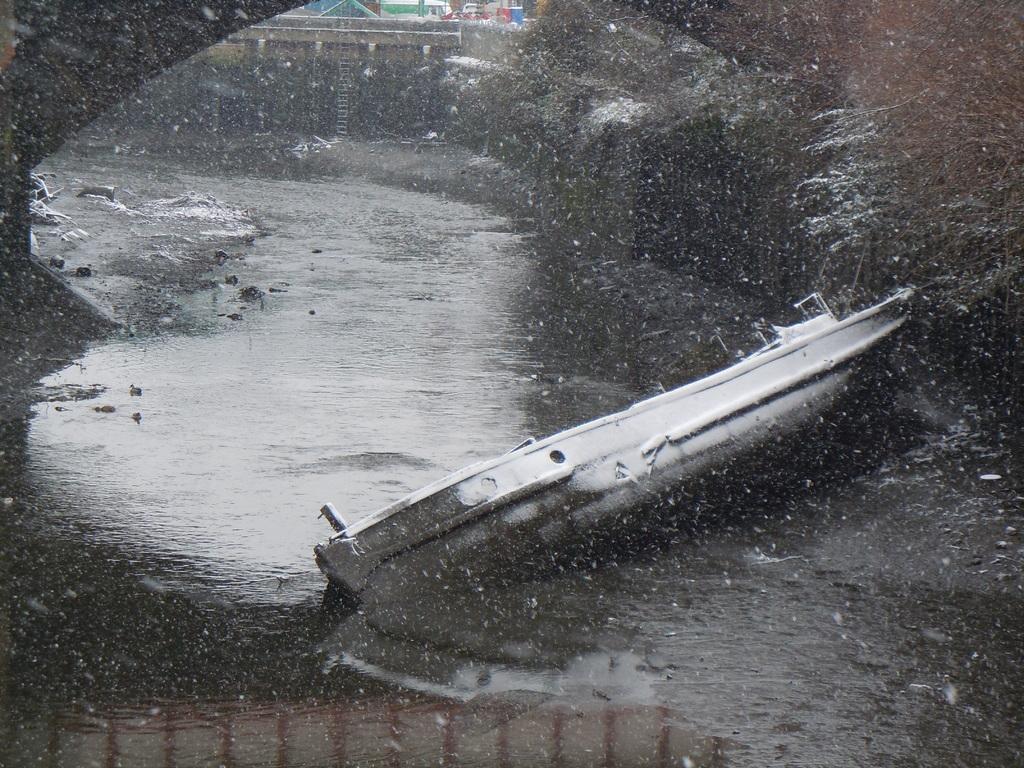Could you give a brief overview of what you see in this image? In this picture I can observe a boat floating on the water. In the bottom I can observe a railing. In the background I can observe lake. 